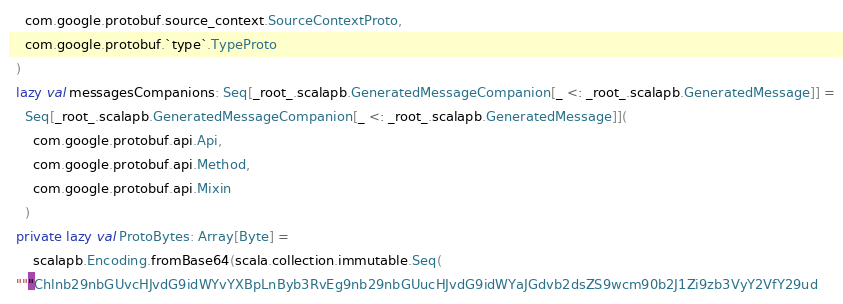<code> <loc_0><loc_0><loc_500><loc_500><_Scala_>    com.google.protobuf.source_context.SourceContextProto,
    com.google.protobuf.`type`.TypeProto
  )
  lazy val messagesCompanions: Seq[_root_.scalapb.GeneratedMessageCompanion[_ <: _root_.scalapb.GeneratedMessage]] =
    Seq[_root_.scalapb.GeneratedMessageCompanion[_ <: _root_.scalapb.GeneratedMessage]](
      com.google.protobuf.api.Api,
      com.google.protobuf.api.Method,
      com.google.protobuf.api.Mixin
    )
  private lazy val ProtoBytes: Array[Byte] =
      scalapb.Encoding.fromBase64(scala.collection.immutable.Seq(
  """Chlnb29nbGUvcHJvdG9idWYvYXBpLnByb3RvEg9nb29nbGUucHJvdG9idWYaJGdvb2dsZS9wcm90b2J1Zi9zb3VyY2VfY29ud</code> 